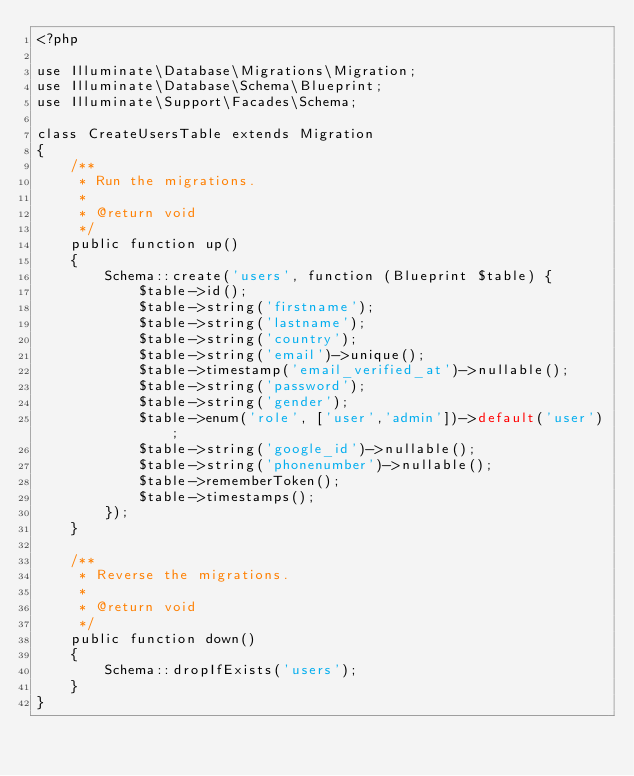<code> <loc_0><loc_0><loc_500><loc_500><_PHP_><?php

use Illuminate\Database\Migrations\Migration;
use Illuminate\Database\Schema\Blueprint;
use Illuminate\Support\Facades\Schema;

class CreateUsersTable extends Migration
{
    /**
     * Run the migrations.
     *
     * @return void
     */
    public function up()
    {
        Schema::create('users', function (Blueprint $table) {
            $table->id();
            $table->string('firstname');
            $table->string('lastname');
            $table->string('country');
            $table->string('email')->unique();
            $table->timestamp('email_verified_at')->nullable();
            $table->string('password');
            $table->string('gender');
            $table->enum('role', ['user','admin'])->default('user');
            $table->string('google_id')->nullable();
            $table->string('phonenumber')->nullable();
            $table->rememberToken();
            $table->timestamps();
        });
    }

    /**
     * Reverse the migrations.
     *
     * @return void
     */
    public function down()
    {
        Schema::dropIfExists('users');
    }
}
</code> 